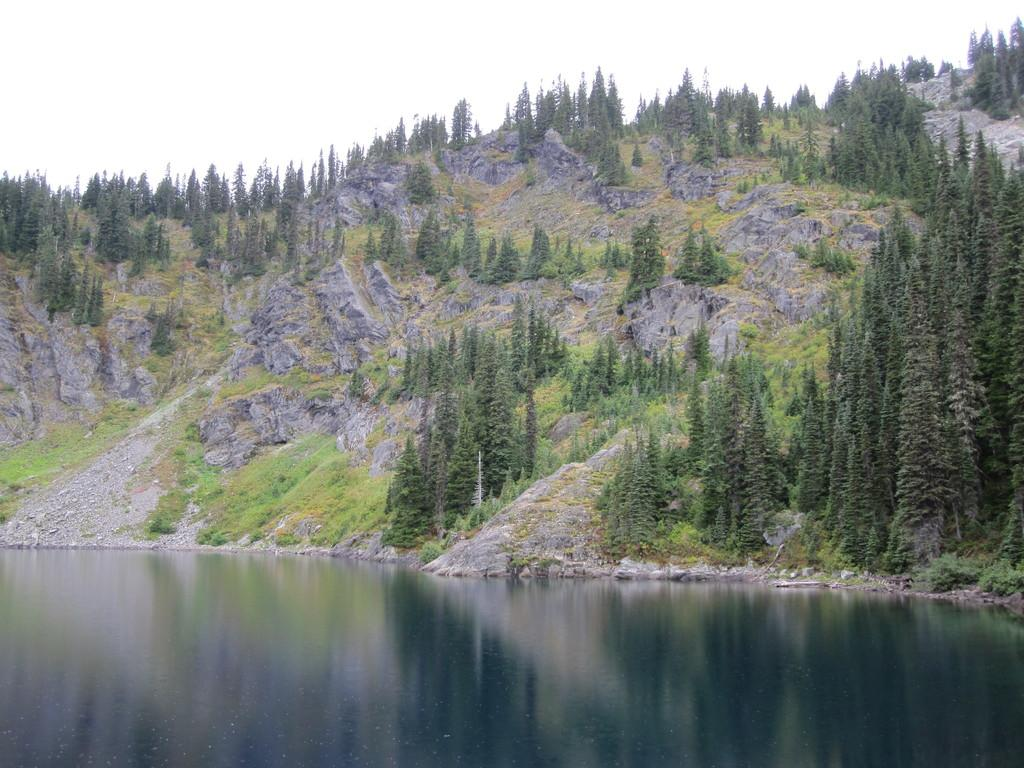What is present at the bottom of the image? There is water at the bottom side of the image. What type of vegetation can be seen in the image? There are trees in the image. What geographical feature is visible in the image? There are mountains in the image. Can you tell me how many insects are crawling on the faucet in the image? There is no faucet present in the image, and therefore no insects can be observed on it. What type of duck can be seen swimming in the water in the image? There is no duck present in the image; it only features water, trees, and mountains. 